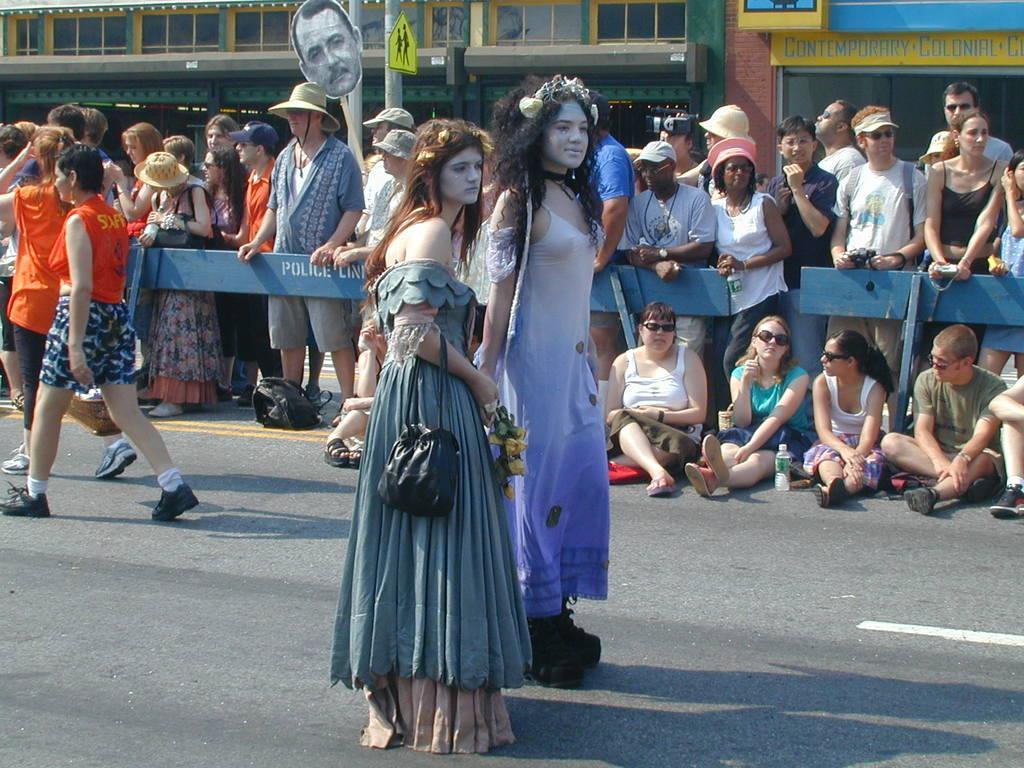In one or two sentences, can you explain what this image depicts? In this image I can see number of people where few are sitting on the road and rest all are standing. In the front I can see two women are wearing costumes. I can also see most of the people are wearing caps and few people are carrying bags. On the right side of the image I can see two persons are holding cameras. On the top side of the image I can see few buildings, few boards, few poles and on these boards I can see something is written. 